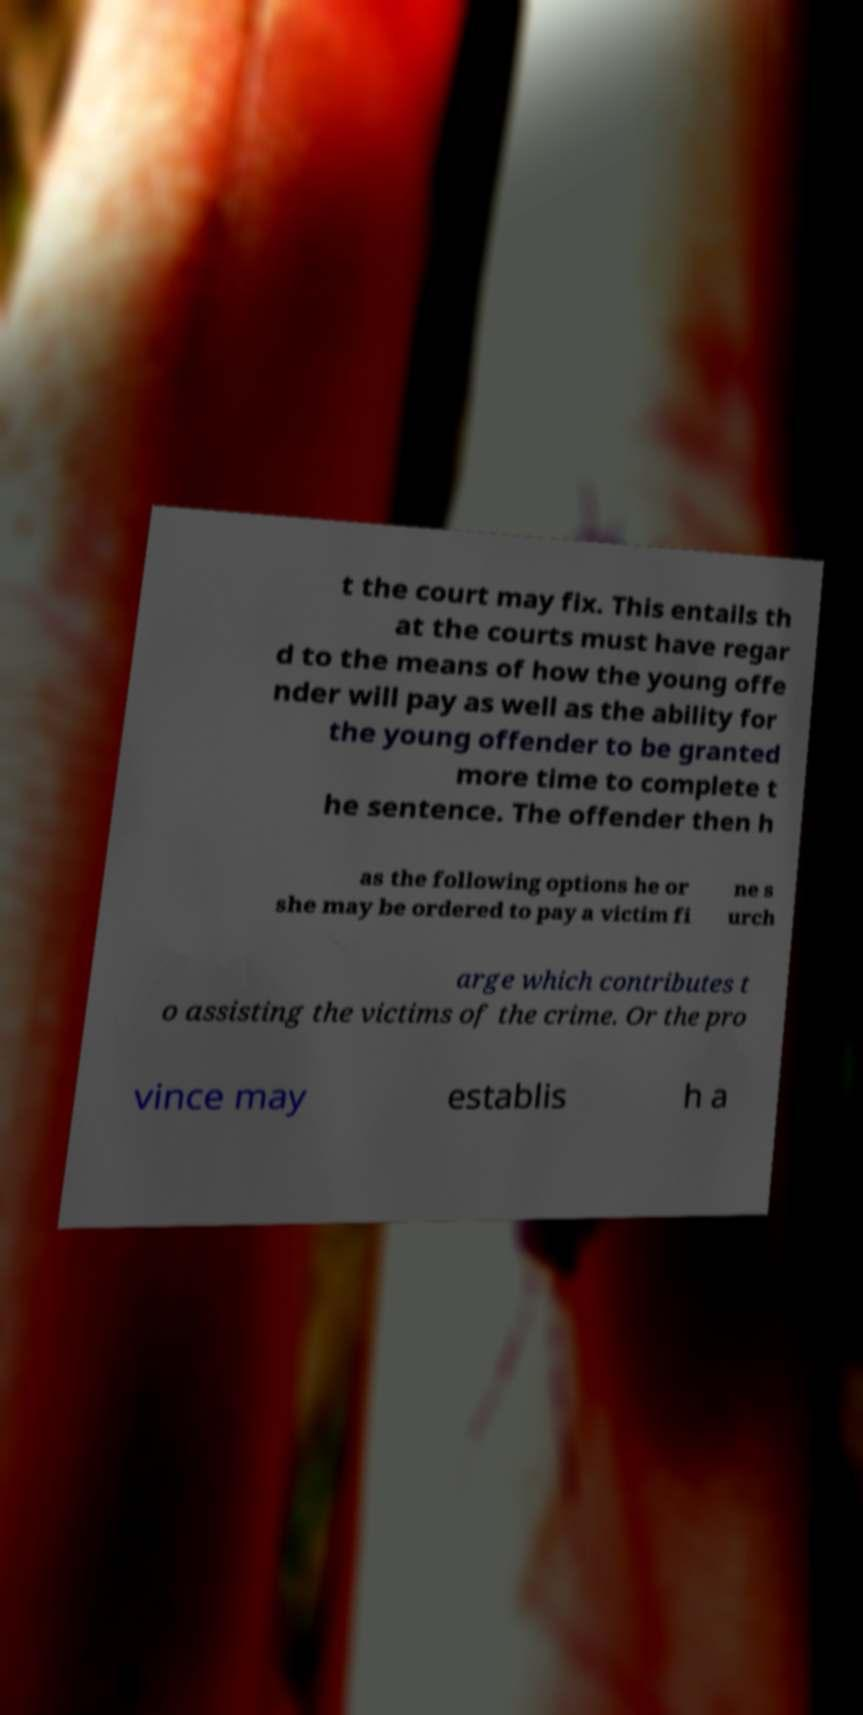Could you extract and type out the text from this image? t the court may fix. This entails th at the courts must have regar d to the means of how the young offe nder will pay as well as the ability for the young offender to be granted more time to complete t he sentence. The offender then h as the following options he or she may be ordered to pay a victim fi ne s urch arge which contributes t o assisting the victims of the crime. Or the pro vince may establis h a 